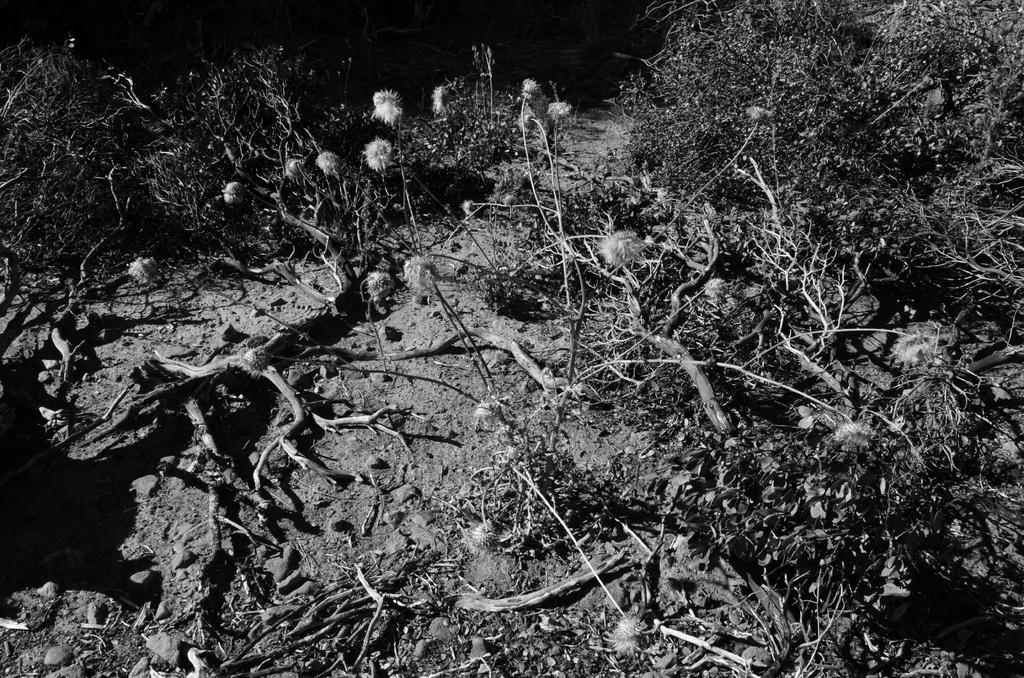What type of living organisms can be seen in the image? Plants and flowers are visible in the image. Can you describe the flowers in the image? The flowers in the image are part of the plants and add color and beauty to the scene. Is there a person sleeping in a crib in the image? No, there is no person or crib present in the image; it only features plants and flowers. 